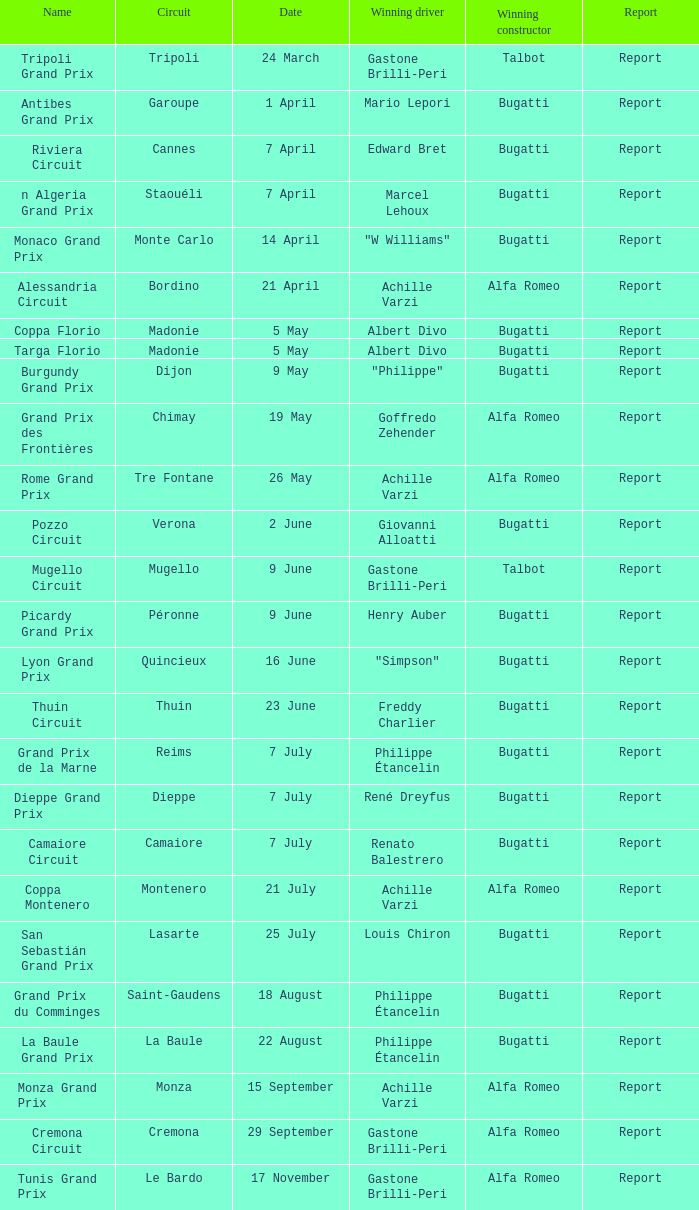What Date has a Name of thuin circuit? 23 June. 